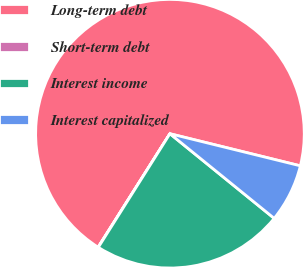Convert chart. <chart><loc_0><loc_0><loc_500><loc_500><pie_chart><fcel>Long-term debt<fcel>Short-term debt<fcel>Interest income<fcel>Interest capitalized<nl><fcel>69.86%<fcel>0.03%<fcel>23.1%<fcel>7.01%<nl></chart> 